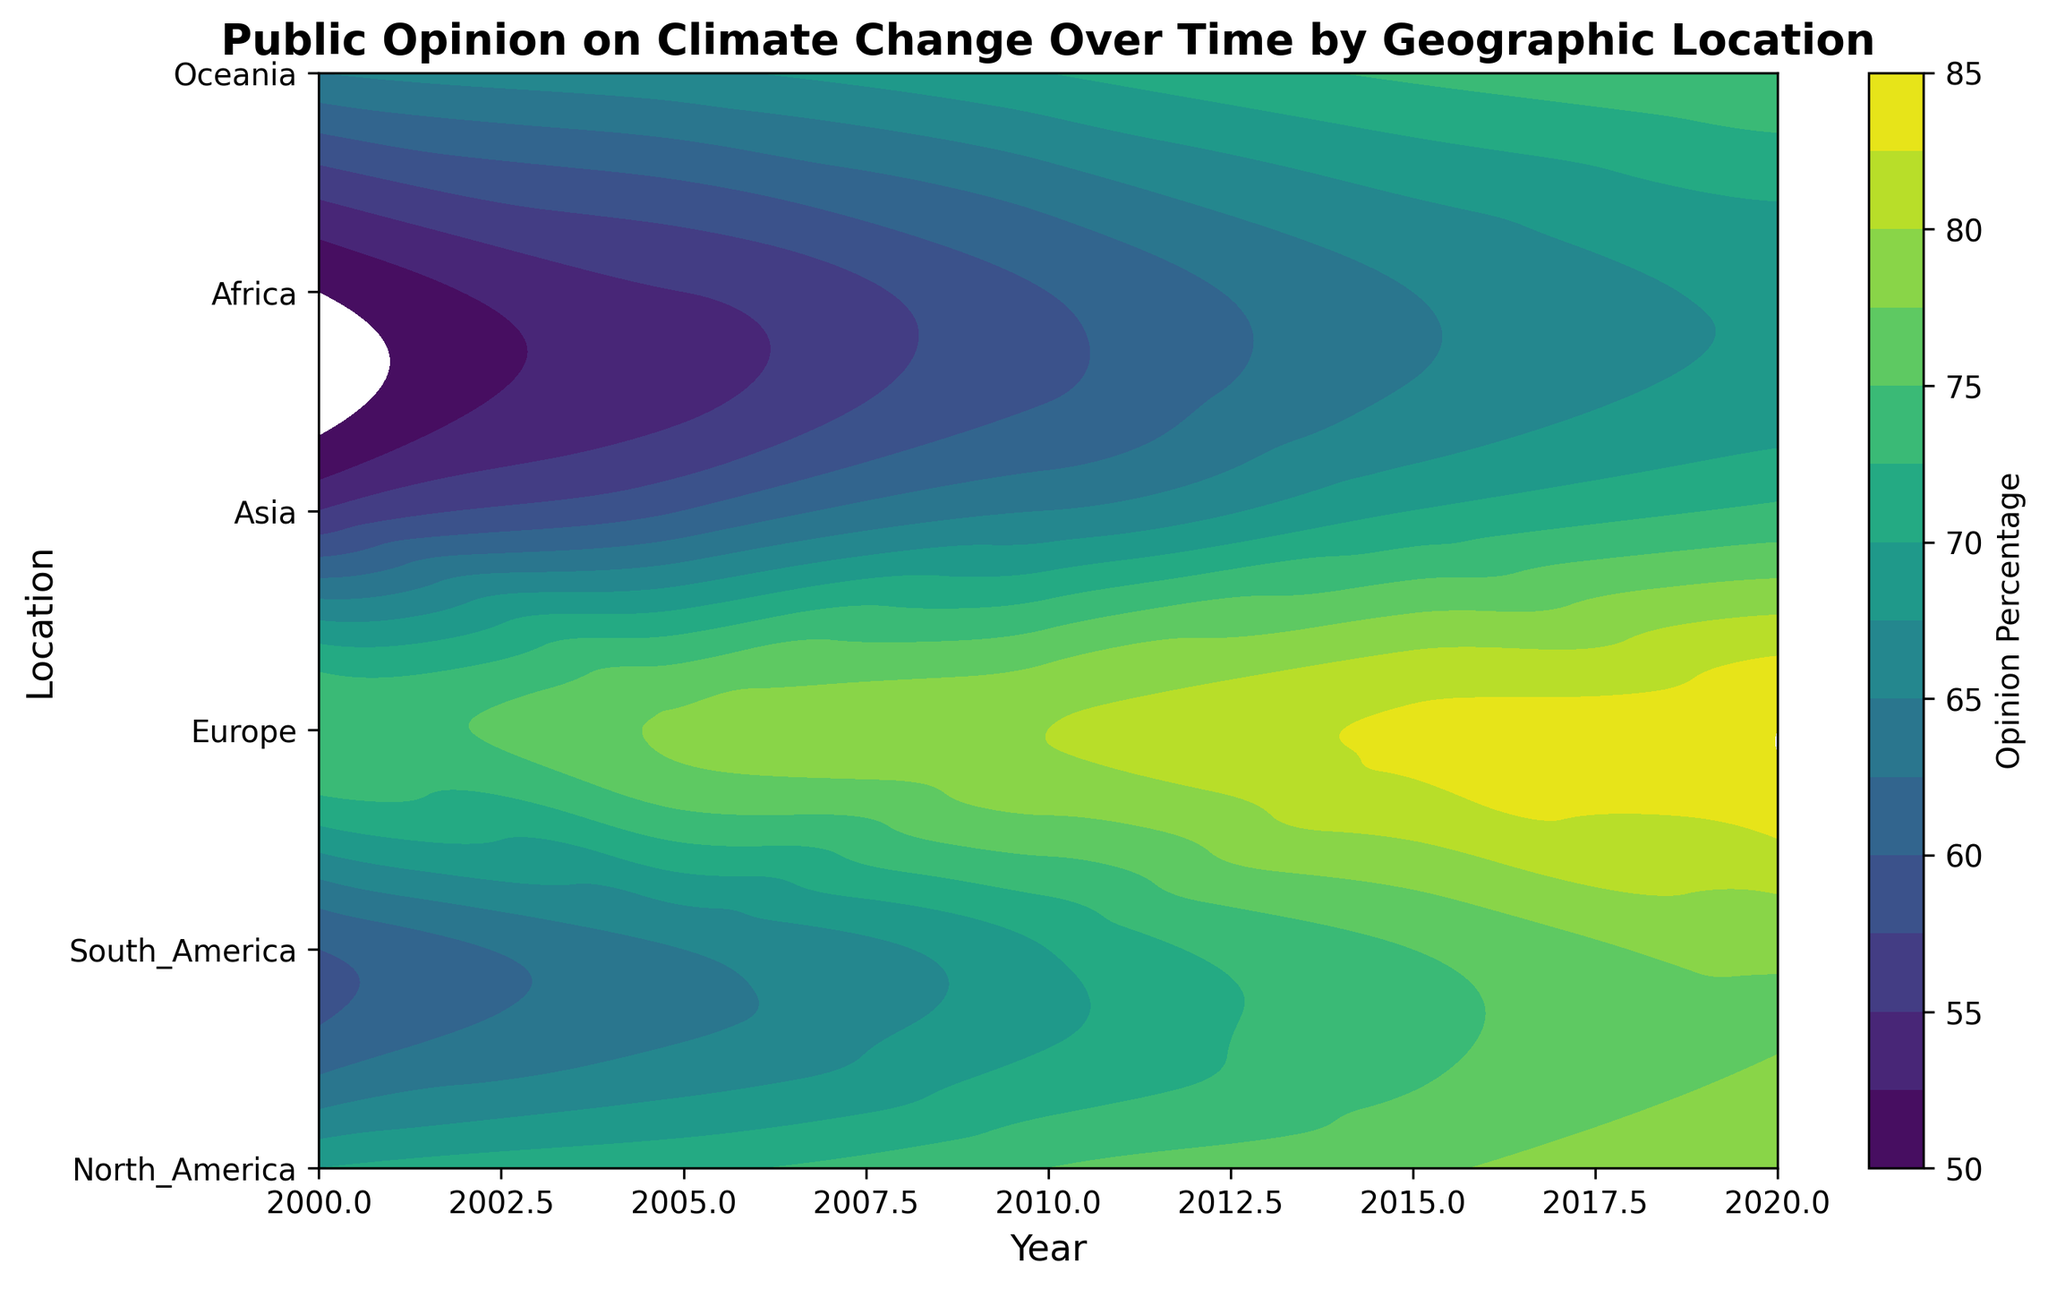What trends can be observed in public opinion on climate change in North America over the years? By looking at the contour plot, observe the changes in color over the years for North America. The color becomes progressively darker, indicating an increasing percentage of people concerned about climate change from 2000 to 2020.
Answer: Increasing trend Which continent shows the highest percentage of public opinion on climate change in 2020? Locate the year 2020 on the x-axis and find the corresponding contour levels for each continent. Europe exhibits the darkest shade, indicating the highest percentage.
Answer: Europe How does the public opinion on climate change in Africa in 2020 compare to the opinion in Asia in 2010? Find the contour levels for Africa in 2020 and Asia in 2010. The colors for Africa in 2020 are similar to or slightly lighter than Asia in 2010, representing a similar or slightly lower percentage.
Answer: Similar or lower What is the difference in public opinion on climate change between Europe and Oceania in the year 2000? Locate the contour levels for Europe and Oceania in 2000. Europe starts with 75% and Oceania with 65%, so the difference is 75% - 65% = 10%.
Answer: 10% Which two continents show the closest opinion percentages in 2015? Compare the contour shades for all continents in 2015. North America and Oceania show the closest values (both around 73-77%).
Answer: North America and Oceania Which years show the highest rate of increase in public opinion on climate change for South America? Identify the steepest gradient in the contour levels for South America. The most rapid increases appear between 2000-2010 and again between 2015-2020.
Answer: 2000-2010 and 2015-2020 Overall, which continent has shown the most significant increase in public opinion on climate change from 2000 to 2020? Identify the change in contour levels from 2000 to 2020 for all continents. Africa, starting from the lowest value in 2000 and ending with a relatively high value in 2020, indicates the most significant increase.
Answer: Africa Do any continents display a decline in public opinion on climate change? Review the contour plot for any sections where the color-lightness decreases over time. No continents exhibit a decline in public opinion over the years; all show an upward trend.
Answer: None On average, which continent has the least change in public opinion on climate change over the 20-year period? Calculate the difference in the shades of contour levels for each continent from 2000 to 2020, and find the lowest value of change. Oceania shows one of the smallest increases, indicating the least change in opinion.
Answer: Oceania 